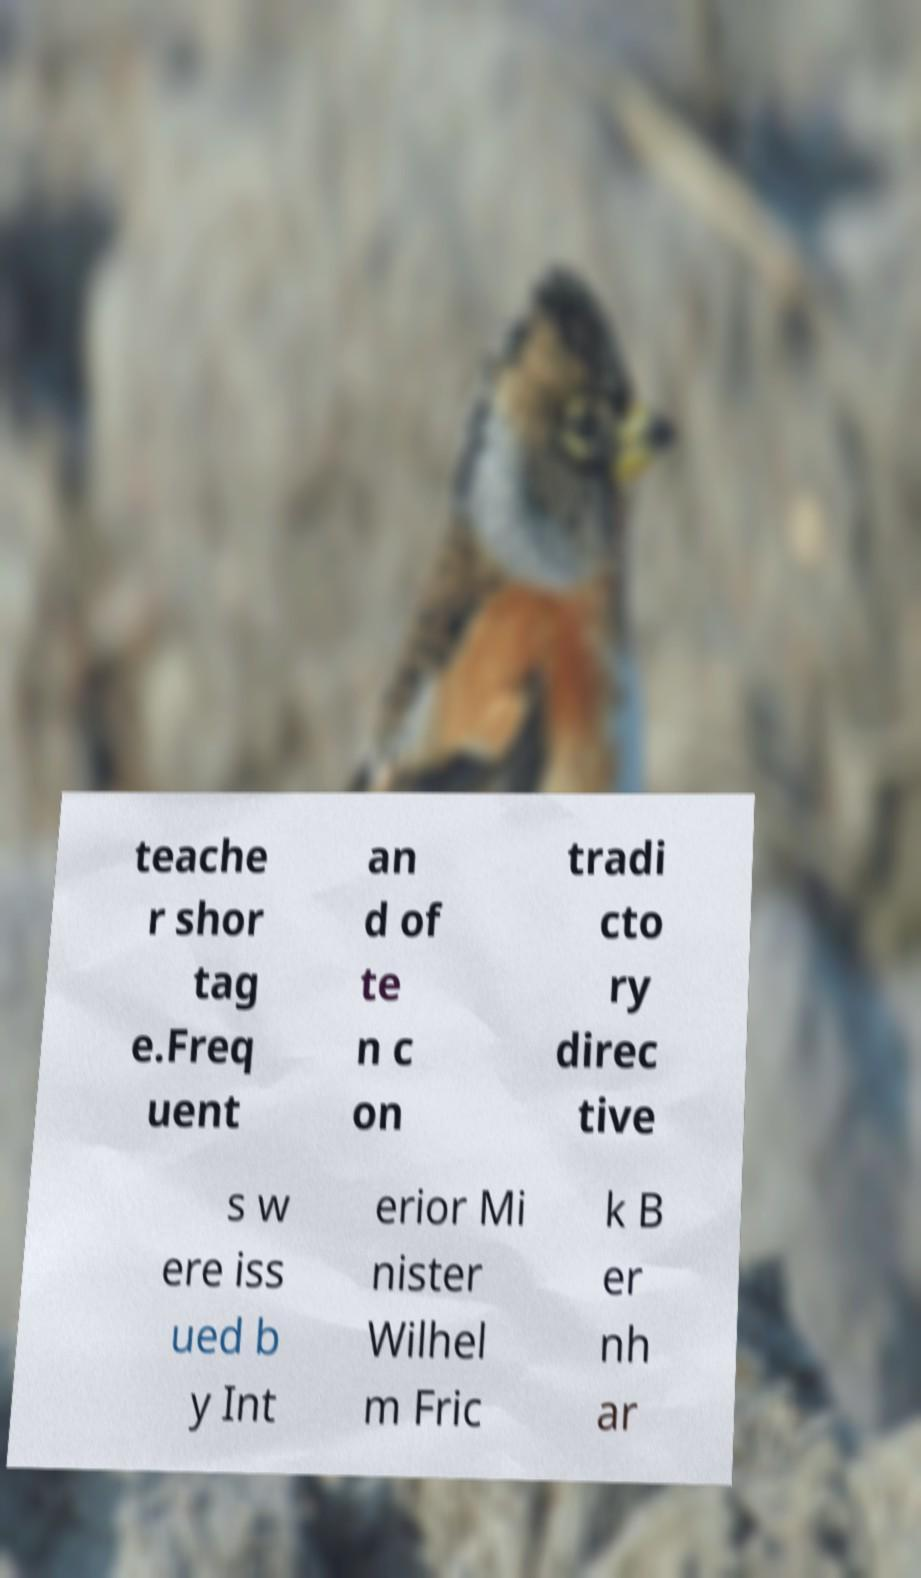I need the written content from this picture converted into text. Can you do that? teache r shor tag e.Freq uent an d of te n c on tradi cto ry direc tive s w ere iss ued b y Int erior Mi nister Wilhel m Fric k B er nh ar 